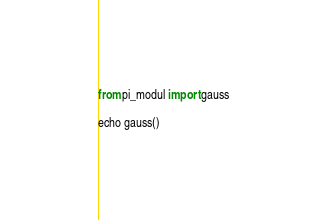Convert code to text. <code><loc_0><loc_0><loc_500><loc_500><_Nim_>from pi_modul import gauss

echo gauss()</code> 